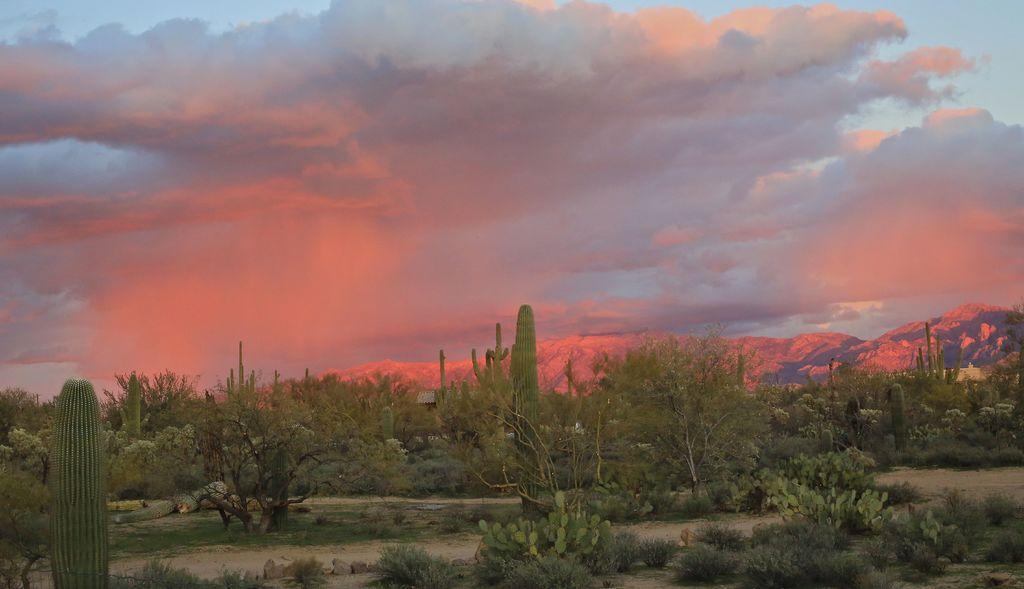Describe this image in one or two sentences. In this image we can see the trees, plants, grass, stones and also the sand. In the background we can see the mountains and also the sky with the clouds. 